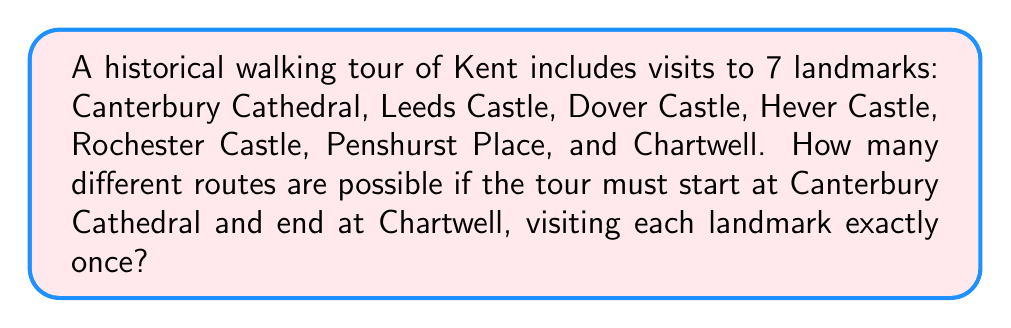Solve this math problem. Let's approach this step-by-step:

1) We start with Canterbury Cathedral and end with Chartwell, so these two landmarks are fixed in their positions.

2) We need to arrange the remaining 5 landmarks (Leeds Castle, Dover Castle, Hever Castle, Rochester Castle, and Penshurst Place) in between.

3) This is a permutation problem. We are arranging 5 objects (the remaining landmarks) in 5 positions.

4) The number of permutations of n distinct objects is given by the formula:

   $$P(n) = n!$$

5) In this case, n = 5, so we calculate:

   $$P(5) = 5! = 5 \times 4 \times 3 \times 2 \times 1 = 120$$

6) Therefore, there are 120 different ways to arrange the 5 landmarks between Canterbury Cathedral and Chartwell.

This gives us the total number of possible routes for the historical walking tour.
Answer: 120 